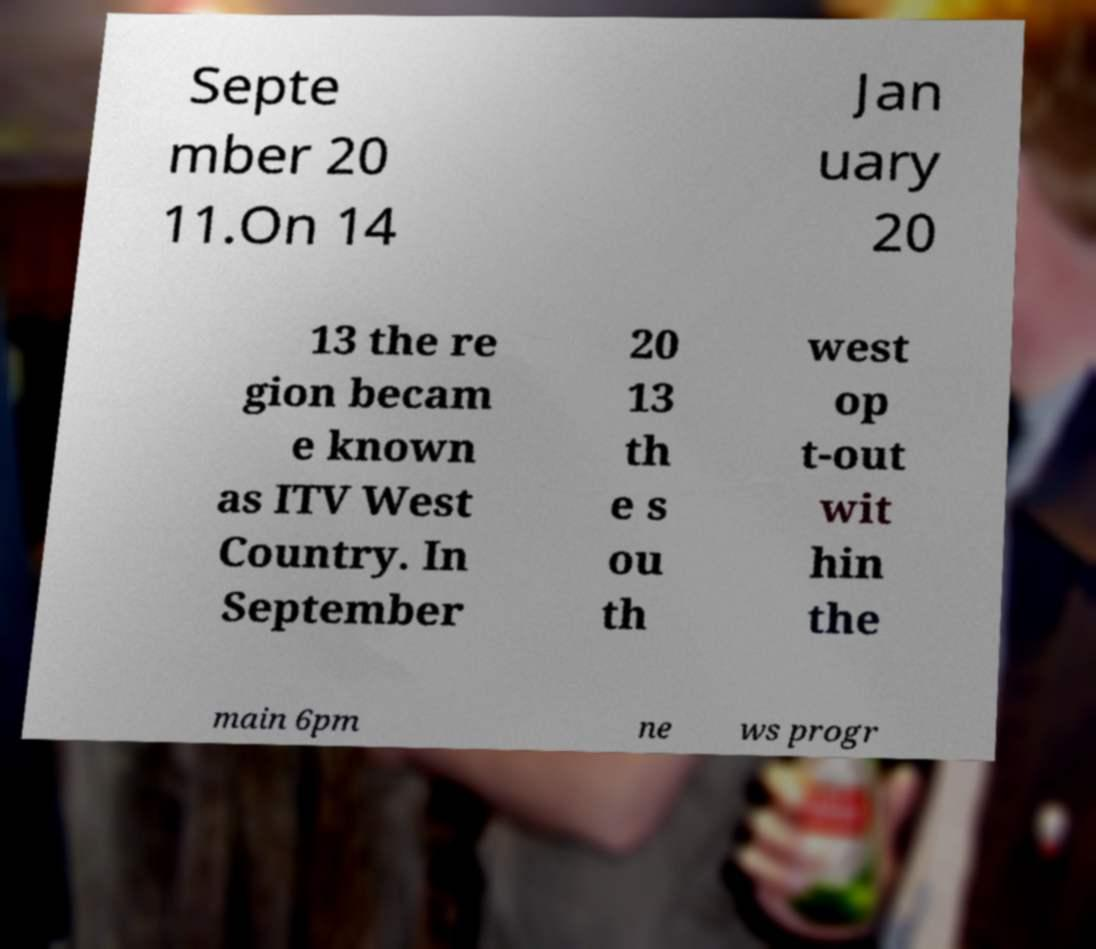Can you accurately transcribe the text from the provided image for me? Septe mber 20 11.On 14 Jan uary 20 13 the re gion becam e known as ITV West Country. In September 20 13 th e s ou th west op t-out wit hin the main 6pm ne ws progr 